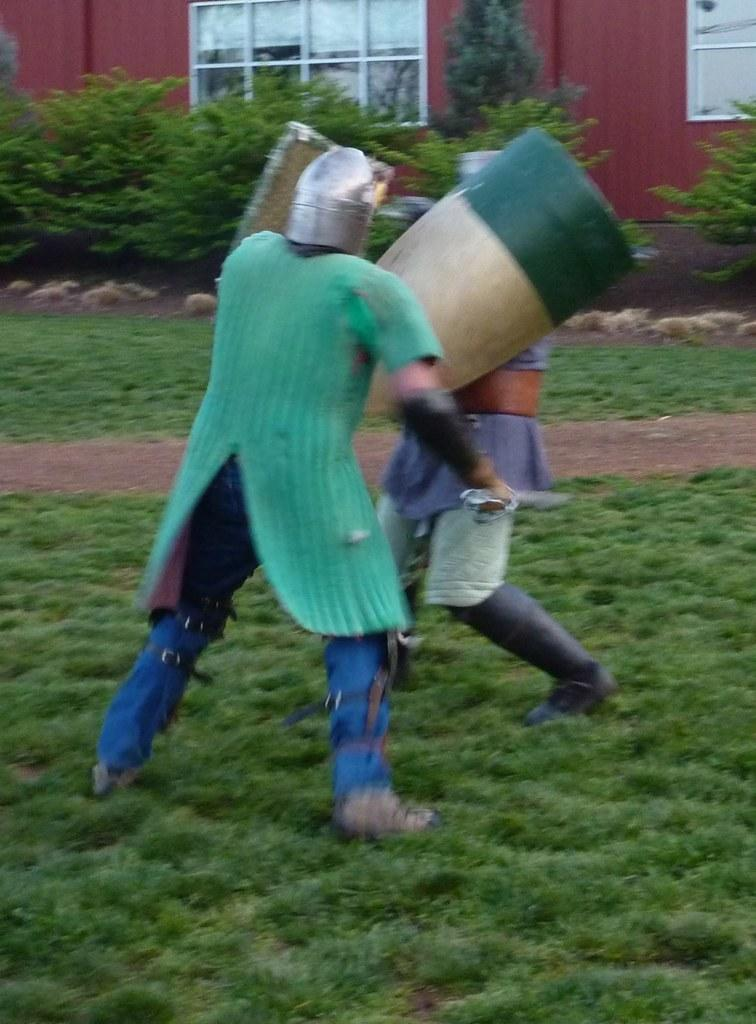How many people are present in the image? There are two people in the image. What are the people holding in the image? The people are holding objects. What type of natural elements can be seen in the image? There are stones, plants, grass, and a wall in the image. What architectural features are visible in the image? There are windows in the image. What type of industry can be seen in the image? There is no industry present in the image. What is the heart rate of the person on the left in the image? There is no information about the person's heart rate in the image. 